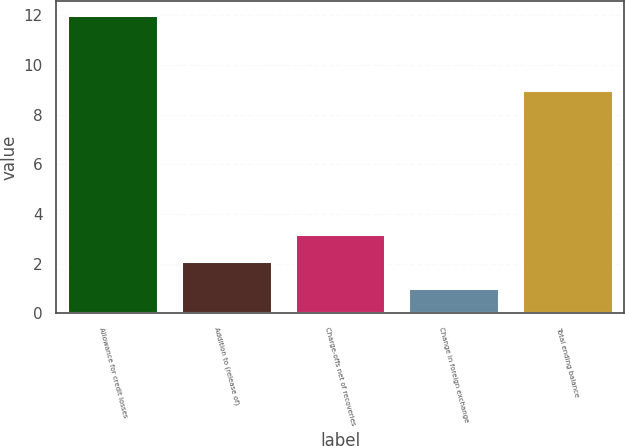Convert chart. <chart><loc_0><loc_0><loc_500><loc_500><bar_chart><fcel>Allowance for credit losses<fcel>Addition to (release of)<fcel>Charge-offs net of recoveries<fcel>Change in foreign exchange<fcel>Total ending balance<nl><fcel>12<fcel>2.1<fcel>3.2<fcel>1<fcel>9<nl></chart> 